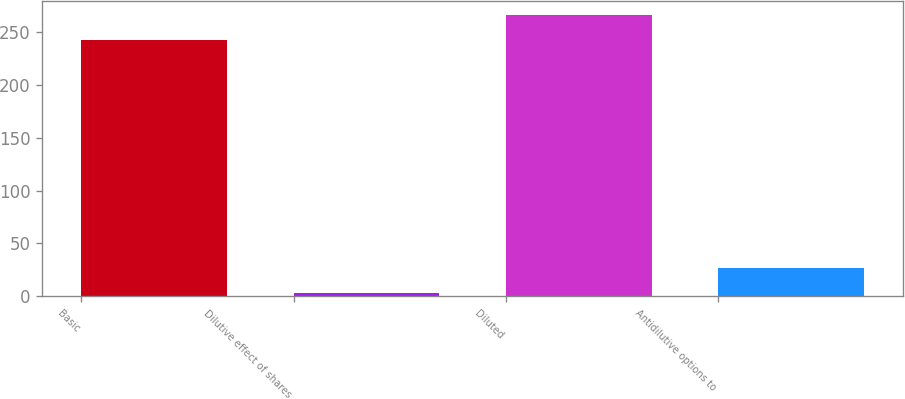<chart> <loc_0><loc_0><loc_500><loc_500><bar_chart><fcel>Basic<fcel>Dilutive effect of shares<fcel>Diluted<fcel>Antidilutive options to<nl><fcel>242.4<fcel>2.9<fcel>266.64<fcel>27.14<nl></chart> 